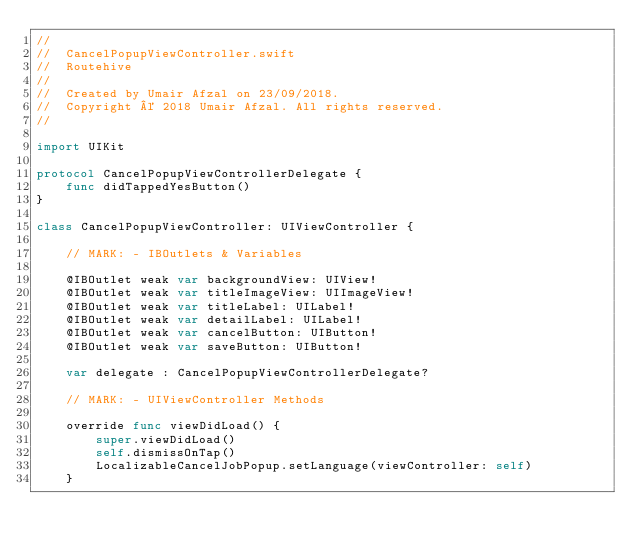Convert code to text. <code><loc_0><loc_0><loc_500><loc_500><_Swift_>//
//  CancelPopupViewController.swift
//  Routehive
//
//  Created by Umair Afzal on 23/09/2018.
//  Copyright © 2018 Umair Afzal. All rights reserved.
//

import UIKit

protocol CancelPopupViewControllerDelegate {
    func didTappedYesButton()
}

class CancelPopupViewController: UIViewController {

    // MARK: - IBOutlets & Variables
    
    @IBOutlet weak var backgroundView: UIView!
    @IBOutlet weak var titleImageView: UIImageView!
    @IBOutlet weak var titleLabel: UILabel!
    @IBOutlet weak var detailLabel: UILabel!
    @IBOutlet weak var cancelButton: UIButton!
    @IBOutlet weak var saveButton: UIButton!
    
    var delegate : CancelPopupViewControllerDelegate?
    
    // MARK: - UIViewController Methods
    
    override func viewDidLoad() {
        super.viewDidLoad()
        self.dismissOnTap()
        LocalizableCancelJobPopup.setLanguage(viewController: self)
    }
    </code> 